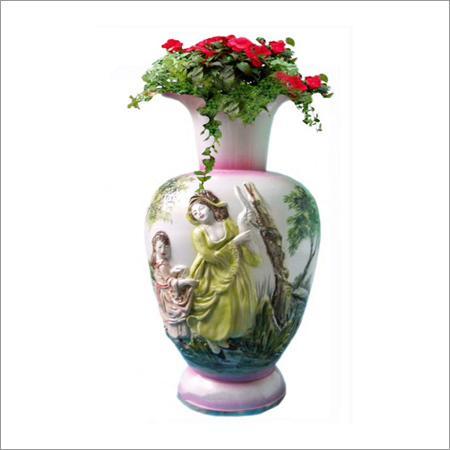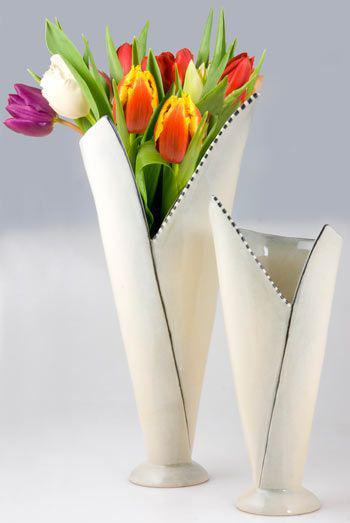The first image is the image on the left, the second image is the image on the right. Analyze the images presented: Is the assertion "The right image contains at least two flower vases." valid? Answer yes or no. Yes. The first image is the image on the left, the second image is the image on the right. Evaluate the accuracy of this statement regarding the images: "there is a vase with at least one tulip in it". Is it true? Answer yes or no. Yes. 